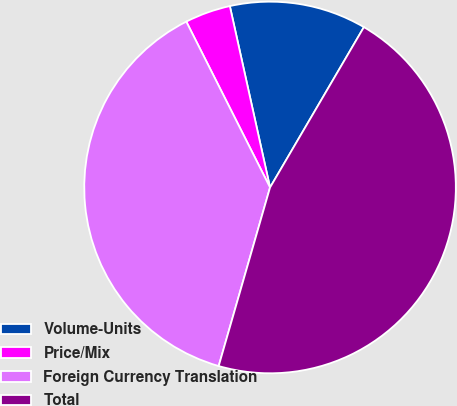<chart> <loc_0><loc_0><loc_500><loc_500><pie_chart><fcel>Volume-Units<fcel>Price/Mix<fcel>Foreign Currency Translation<fcel>Total<nl><fcel>11.9%<fcel>3.97%<fcel>38.1%<fcel>46.03%<nl></chart> 